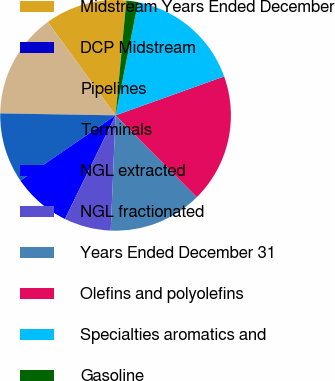Convert chart. <chart><loc_0><loc_0><loc_500><loc_500><pie_chart><fcel>Midstream Years Ended December<fcel>DCP Midstream<fcel>Pipelines<fcel>Terminals<fcel>NGL extracted<fcel>NGL fractionated<fcel>Years Ended December 31<fcel>Olefins and polyolefins<fcel>Specialties aromatics and<fcel>Gasoline<nl><fcel>11.48%<fcel>0.0%<fcel>14.75%<fcel>9.84%<fcel>8.2%<fcel>6.56%<fcel>13.11%<fcel>18.03%<fcel>16.39%<fcel>1.64%<nl></chart> 